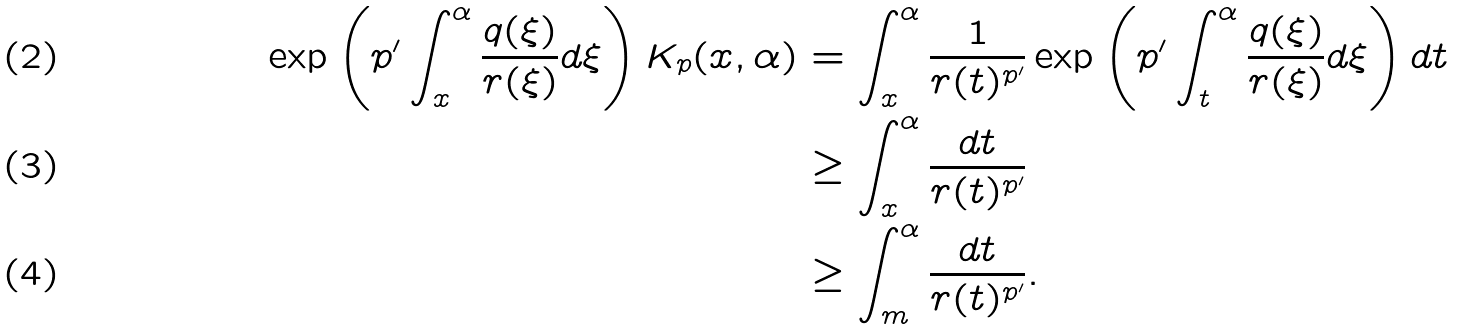<formula> <loc_0><loc_0><loc_500><loc_500>\exp \left ( p ^ { \prime } \int _ { x } ^ { \alpha } \frac { q ( \xi ) } { r ( \xi ) } d \xi \right ) K _ { p } ( x , \alpha ) & = \int _ { x } ^ { \alpha } \frac { 1 } { r ( t ) ^ { p ^ { \prime } } } \exp \left ( p ^ { \prime } \int _ { t } ^ { \alpha } \frac { q ( \xi ) } { r ( \xi ) } d \xi \right ) d t \\ & \geq \int _ { x } ^ { \alpha } \frac { d t } { r ( t ) ^ { p ^ { \prime } } } \\ & \geq \int _ { m } ^ { \alpha } \frac { d t } { r ( t ) ^ { p ^ { \prime } } } .</formula> 